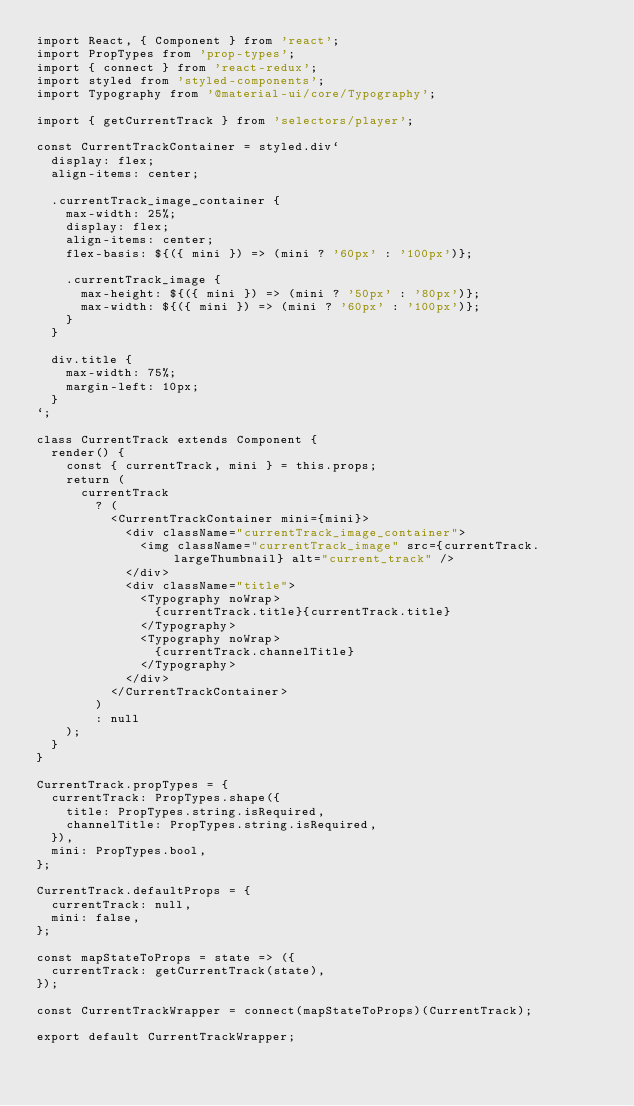Convert code to text. <code><loc_0><loc_0><loc_500><loc_500><_JavaScript_>import React, { Component } from 'react';
import PropTypes from 'prop-types';
import { connect } from 'react-redux';
import styled from 'styled-components';
import Typography from '@material-ui/core/Typography';

import { getCurrentTrack } from 'selectors/player';

const CurrentTrackContainer = styled.div`
  display: flex;
  align-items: center;

  .currentTrack_image_container {
    max-width: 25%;
    display: flex;
    align-items: center;
    flex-basis: ${({ mini }) => (mini ? '60px' : '100px')};

    .currentTrack_image {
      max-height: ${({ mini }) => (mini ? '50px' : '80px')};
      max-width: ${({ mini }) => (mini ? '60px' : '100px')};
    }
  }

  div.title {
    max-width: 75%;
    margin-left: 10px;
  }
`;

class CurrentTrack extends Component {
  render() {
    const { currentTrack, mini } = this.props;
    return (
      currentTrack
        ? (
          <CurrentTrackContainer mini={mini}>
            <div className="currentTrack_image_container">
              <img className="currentTrack_image" src={currentTrack.largeThumbnail} alt="current_track" />
            </div>
            <div className="title">
              <Typography noWrap>
                {currentTrack.title}{currentTrack.title}
              </Typography>
              <Typography noWrap>
                {currentTrack.channelTitle}
              </Typography>
            </div>
          </CurrentTrackContainer>
        )
        : null
    );
  }
}

CurrentTrack.propTypes = {
  currentTrack: PropTypes.shape({
    title: PropTypes.string.isRequired,
    channelTitle: PropTypes.string.isRequired,
  }),
  mini: PropTypes.bool,
};

CurrentTrack.defaultProps = {
  currentTrack: null,
  mini: false,
};

const mapStateToProps = state => ({
  currentTrack: getCurrentTrack(state),
});

const CurrentTrackWrapper = connect(mapStateToProps)(CurrentTrack);

export default CurrentTrackWrapper;
</code> 